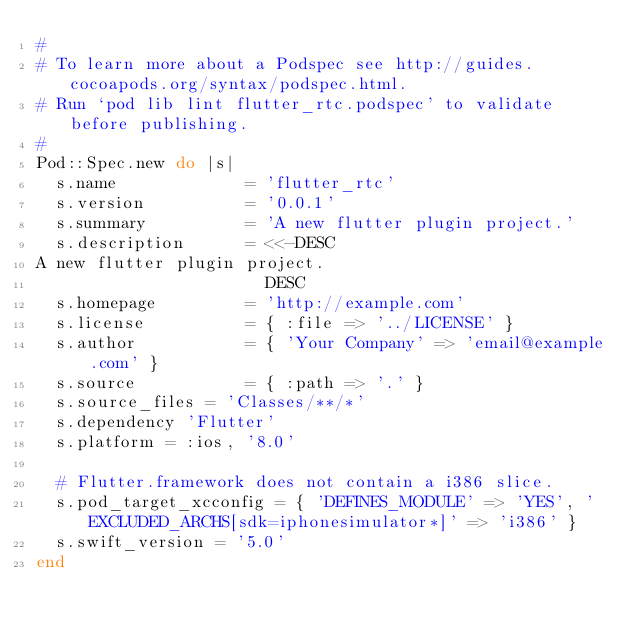<code> <loc_0><loc_0><loc_500><loc_500><_Ruby_>#
# To learn more about a Podspec see http://guides.cocoapods.org/syntax/podspec.html.
# Run `pod lib lint flutter_rtc.podspec' to validate before publishing.
#
Pod::Spec.new do |s|
  s.name             = 'flutter_rtc'
  s.version          = '0.0.1'
  s.summary          = 'A new flutter plugin project.'
  s.description      = <<-DESC
A new flutter plugin project.
                       DESC
  s.homepage         = 'http://example.com'
  s.license          = { :file => '../LICENSE' }
  s.author           = { 'Your Company' => 'email@example.com' }
  s.source           = { :path => '.' }
  s.source_files = 'Classes/**/*'
  s.dependency 'Flutter'
  s.platform = :ios, '8.0'

  # Flutter.framework does not contain a i386 slice.
  s.pod_target_xcconfig = { 'DEFINES_MODULE' => 'YES', 'EXCLUDED_ARCHS[sdk=iphonesimulator*]' => 'i386' }
  s.swift_version = '5.0'
end
</code> 